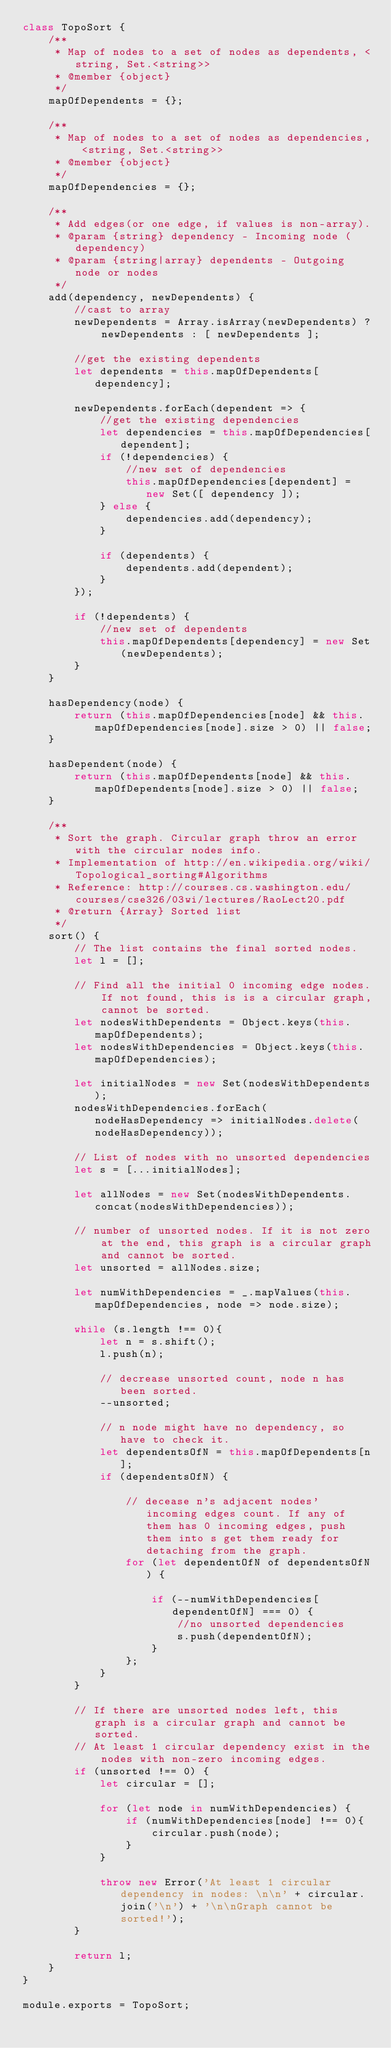Convert code to text. <code><loc_0><loc_0><loc_500><loc_500><_JavaScript_>class TopoSort {    
    /**
     * Map of nodes to a set of nodes as dependents, <string, Set.<string>>
     * @member {object}
     */
    mapOfDependents = {};

    /**
     * Map of nodes to a set of nodes as dependencies, <string, Set.<string>>
     * @member {object}
     */
    mapOfDependencies = {};

    /**
     * Add edges(or one edge, if values is non-array).
     * @param {string} dependency - Incoming node (dependency)
     * @param {string|array} dependents - Outgoing node or nodes
     */
    add(dependency, newDependents) {
        //cast to array
        newDependents = Array.isArray(newDependents) ? newDependents : [ newDependents ];

        //get the existing dependents
        let dependents = this.mapOfDependents[dependency];

        newDependents.forEach(dependent => {
            //get the existing dependencies
            let dependencies = this.mapOfDependencies[dependent];
            if (!dependencies) {
                //new set of dependencies
                this.mapOfDependencies[dependent] = new Set([ dependency ]); 
            } else {
                dependencies.add(dependency);
            }

            if (dependents) {
                dependents.add(dependent);
            }
        });

        if (!dependents) {
            //new set of dependents
            this.mapOfDependents[dependency] = new Set(newDependents);
        }
    }

    hasDependency(node) {
        return (this.mapOfDependencies[node] && this.mapOfDependencies[node].size > 0) || false;
    }

    hasDependent(node) {
        return (this.mapOfDependents[node] && this.mapOfDependents[node].size > 0) || false;
    }

    /**
     * Sort the graph. Circular graph throw an error with the circular nodes info.
     * Implementation of http://en.wikipedia.org/wiki/Topological_sorting#Algorithms
     * Reference: http://courses.cs.washington.edu/courses/cse326/03wi/lectures/RaoLect20.pdf
     * @return {Array} Sorted list
     */
    sort() {        
        // The list contains the final sorted nodes.
        let l = [];

        // Find all the initial 0 incoming edge nodes. If not found, this is is a circular graph, cannot be sorted.         
        let nodesWithDependents = Object.keys(this.mapOfDependents);
        let nodesWithDependencies = Object.keys(this.mapOfDependencies);

        let initialNodes = new Set(nodesWithDependents);
        nodesWithDependencies.forEach(nodeHasDependency => initialNodes.delete(nodeHasDependency));

        // List of nodes with no unsorted dependencies
        let s = [...initialNodes];

        let allNodes = new Set(nodesWithDependents.concat(nodesWithDependencies));

        // number of unsorted nodes. If it is not zero at the end, this graph is a circular graph and cannot be sorted.
        let unsorted = allNodes.size;

        let numWithDependencies = _.mapValues(this.mapOfDependencies, node => node.size);

        while (s.length !== 0){
            let n = s.shift();
            l.push(n);

            // decrease unsorted count, node n has been sorted.
            --unsorted;

            // n node might have no dependency, so have to check it.
            let dependentsOfN = this.mapOfDependents[n];
            if (dependentsOfN) {
                
                // decease n's adjacent nodes' incoming edges count. If any of them has 0 incoming edges, push them into s get them ready for detaching from the graph.
                for (let dependentOfN of dependentsOfN) {                    

                    if (--numWithDependencies[dependentOfN] === 0) {
                        //no unsorted dependencies
                        s.push(dependentOfN);
                    }
                };
            }
        }

        // If there are unsorted nodes left, this graph is a circular graph and cannot be sorted.
        // At least 1 circular dependency exist in the nodes with non-zero incoming edges.
        if (unsorted !== 0) {
            let circular = [];
            
            for (let node in numWithDependencies) {
                if (numWithDependencies[node] !== 0){
                    circular.push(node);
                }
            }

            throw new Error('At least 1 circular dependency in nodes: \n\n' + circular.join('\n') + '\n\nGraph cannot be sorted!');
        }

        return l;
    }
}

module.exports = TopoSort;</code> 